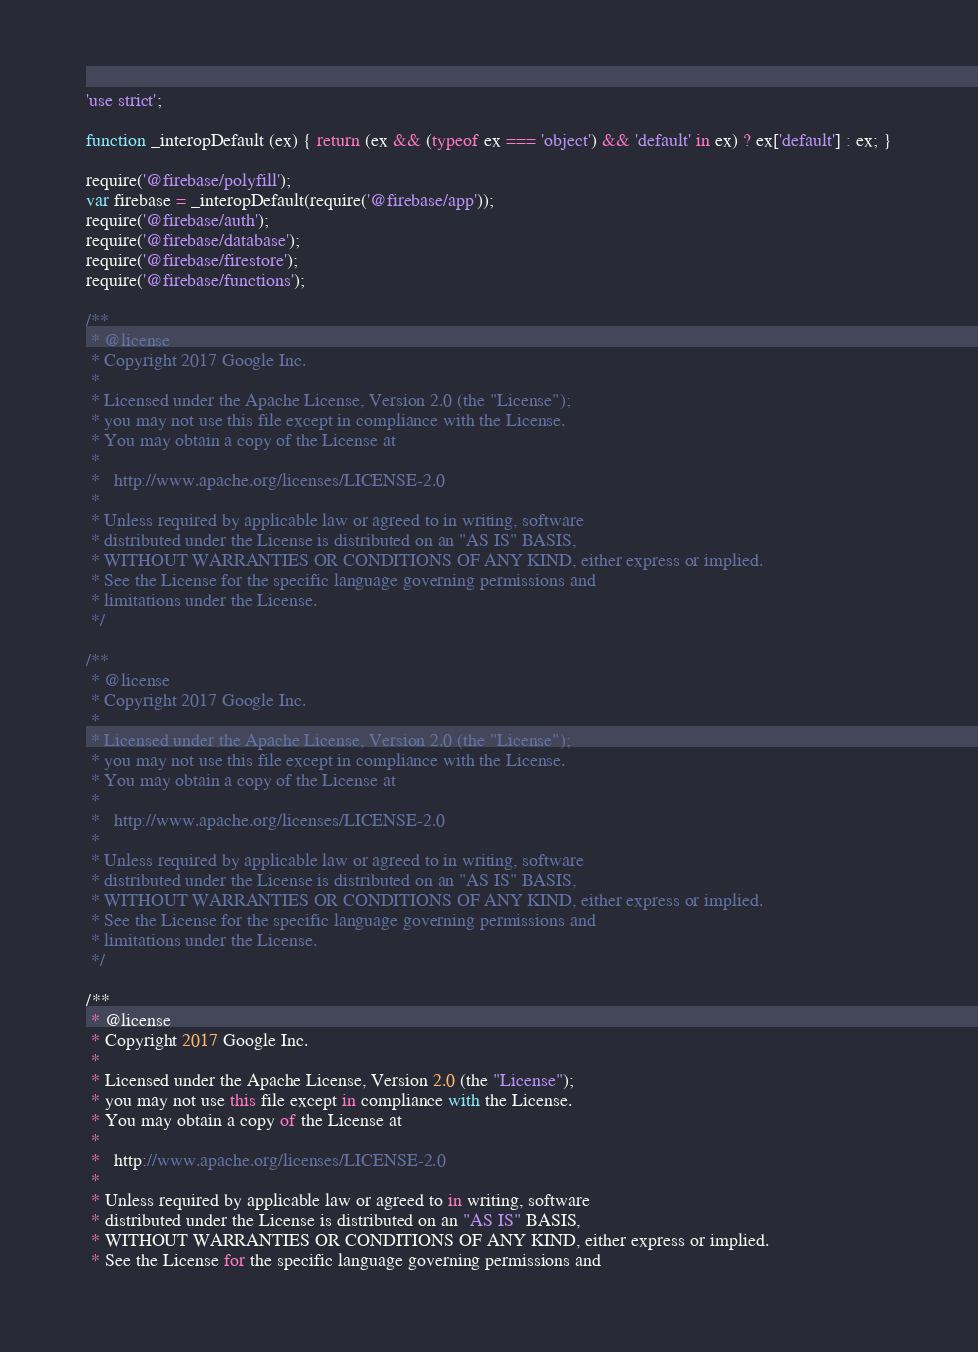Convert code to text. <code><loc_0><loc_0><loc_500><loc_500><_JavaScript_>'use strict';

function _interopDefault (ex) { return (ex && (typeof ex === 'object') && 'default' in ex) ? ex['default'] : ex; }

require('@firebase/polyfill');
var firebase = _interopDefault(require('@firebase/app'));
require('@firebase/auth');
require('@firebase/database');
require('@firebase/firestore');
require('@firebase/functions');

/**
 * @license
 * Copyright 2017 Google Inc.
 *
 * Licensed under the Apache License, Version 2.0 (the "License");
 * you may not use this file except in compliance with the License.
 * You may obtain a copy of the License at
 *
 *   http://www.apache.org/licenses/LICENSE-2.0
 *
 * Unless required by applicable law or agreed to in writing, software
 * distributed under the License is distributed on an "AS IS" BASIS,
 * WITHOUT WARRANTIES OR CONDITIONS OF ANY KIND, either express or implied.
 * See the License for the specific language governing permissions and
 * limitations under the License.
 */

/**
 * @license
 * Copyright 2017 Google Inc.
 *
 * Licensed under the Apache License, Version 2.0 (the "License");
 * you may not use this file except in compliance with the License.
 * You may obtain a copy of the License at
 *
 *   http://www.apache.org/licenses/LICENSE-2.0
 *
 * Unless required by applicable law or agreed to in writing, software
 * distributed under the License is distributed on an "AS IS" BASIS,
 * WITHOUT WARRANTIES OR CONDITIONS OF ANY KIND, either express or implied.
 * See the License for the specific language governing permissions and
 * limitations under the License.
 */

/**
 * @license
 * Copyright 2017 Google Inc.
 *
 * Licensed under the Apache License, Version 2.0 (the "License");
 * you may not use this file except in compliance with the License.
 * You may obtain a copy of the License at
 *
 *   http://www.apache.org/licenses/LICENSE-2.0
 *
 * Unless required by applicable law or agreed to in writing, software
 * distributed under the License is distributed on an "AS IS" BASIS,
 * WITHOUT WARRANTIES OR CONDITIONS OF ANY KIND, either express or implied.
 * See the License for the specific language governing permissions and</code> 